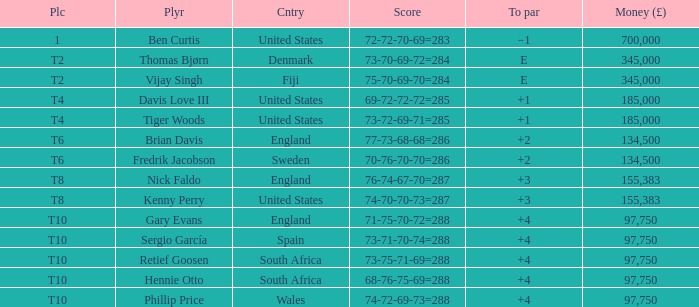What is the Place of Davis Love III with a To Par of +1? T4. 